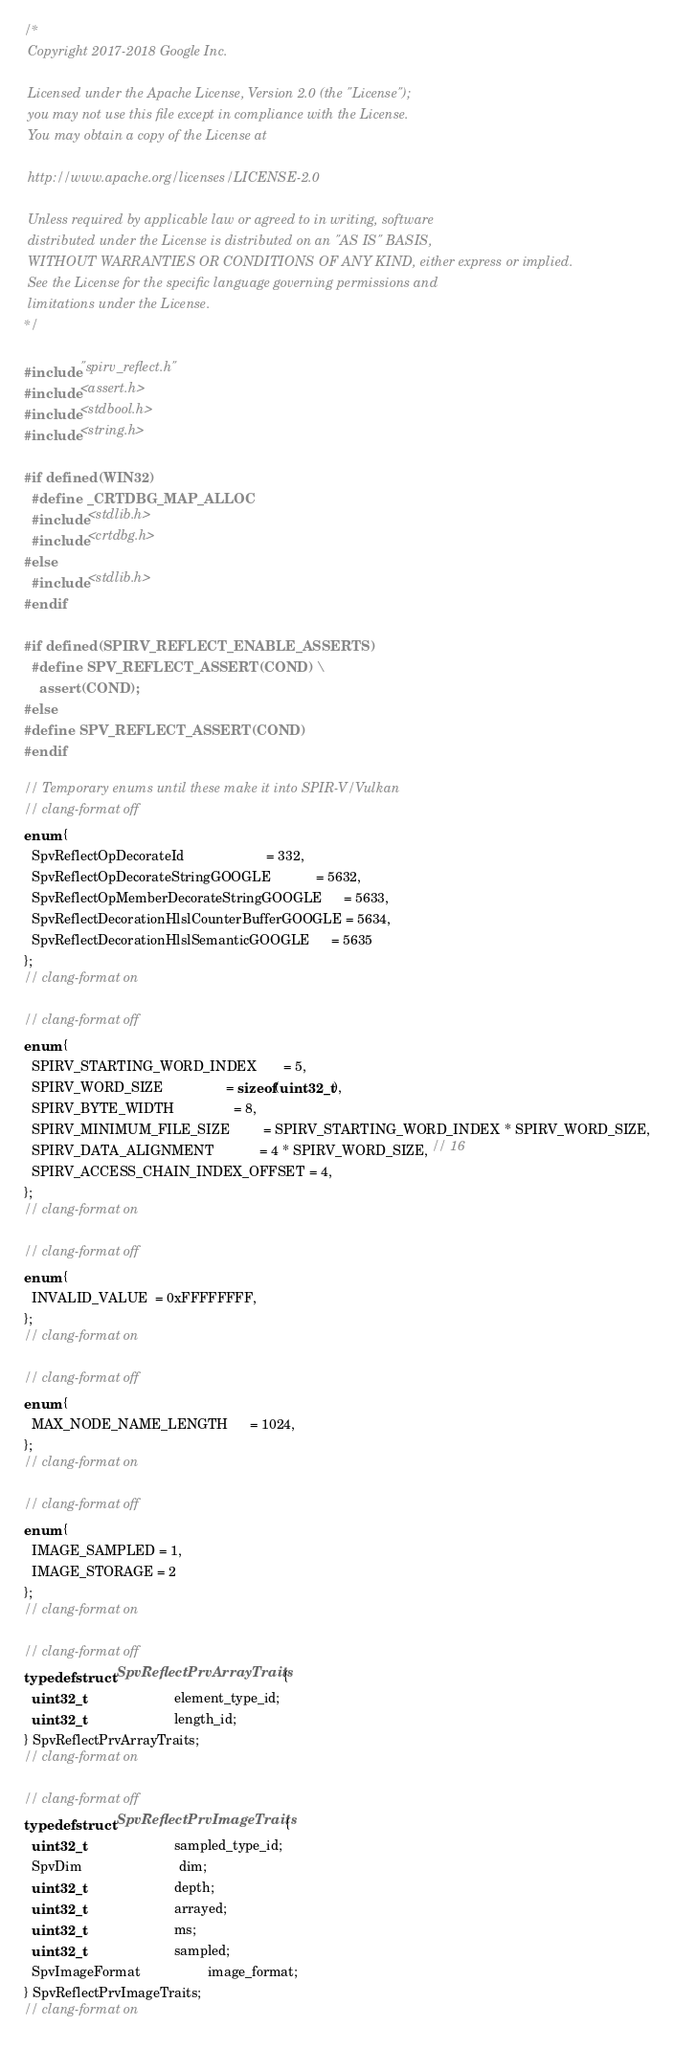<code> <loc_0><loc_0><loc_500><loc_500><_C_>/*
 Copyright 2017-2018 Google Inc.

 Licensed under the Apache License, Version 2.0 (the "License");
 you may not use this file except in compliance with the License.
 You may obtain a copy of the License at

 http://www.apache.org/licenses/LICENSE-2.0

 Unless required by applicable law or agreed to in writing, software
 distributed under the License is distributed on an "AS IS" BASIS,
 WITHOUT WARRANTIES OR CONDITIONS OF ANY KIND, either express or implied.
 See the License for the specific language governing permissions and
 limitations under the License.
*/

#include "spirv_reflect.h"
#include <assert.h>
#include <stdbool.h>
#include <string.h>

#if defined(WIN32)
  #define _CRTDBG_MAP_ALLOC
  #include <stdlib.h>
  #include <crtdbg.h>
#else
  #include <stdlib.h>
#endif

#if defined(SPIRV_REFLECT_ENABLE_ASSERTS)
  #define SPV_REFLECT_ASSERT(COND) \
    assert(COND);
#else
#define SPV_REFLECT_ASSERT(COND)
#endif

// Temporary enums until these make it into SPIR-V/Vulkan
// clang-format off
enum {
  SpvReflectOpDecorateId                      = 332,
  SpvReflectOpDecorateStringGOOGLE            = 5632,
  SpvReflectOpMemberDecorateStringGOOGLE      = 5633,
  SpvReflectDecorationHlslCounterBufferGOOGLE = 5634,
  SpvReflectDecorationHlslSemanticGOOGLE      = 5635
};
// clang-format on

// clang-format off
enum {
  SPIRV_STARTING_WORD_INDEX       = 5,
  SPIRV_WORD_SIZE                 = sizeof(uint32_t),
  SPIRV_BYTE_WIDTH                = 8,
  SPIRV_MINIMUM_FILE_SIZE         = SPIRV_STARTING_WORD_INDEX * SPIRV_WORD_SIZE,
  SPIRV_DATA_ALIGNMENT            = 4 * SPIRV_WORD_SIZE, // 16
  SPIRV_ACCESS_CHAIN_INDEX_OFFSET = 4,
};
// clang-format on

// clang-format off
enum {
  INVALID_VALUE  = 0xFFFFFFFF,
};
// clang-format on

// clang-format off
enum {
  MAX_NODE_NAME_LENGTH      = 1024,
};
// clang-format on

// clang-format off
enum {
  IMAGE_SAMPLED = 1,
  IMAGE_STORAGE = 2
};
// clang-format on

// clang-format off
typedef struct SpvReflectPrvArrayTraits {
  uint32_t                        element_type_id;
  uint32_t                        length_id;
} SpvReflectPrvArrayTraits;
// clang-format on

// clang-format off
typedef struct SpvReflectPrvImageTraits {
  uint32_t                        sampled_type_id;
  SpvDim                          dim;
  uint32_t                        depth;
  uint32_t                        arrayed;
  uint32_t                        ms;
  uint32_t                        sampled;
  SpvImageFormat                  image_format;
} SpvReflectPrvImageTraits;
// clang-format on
</code> 